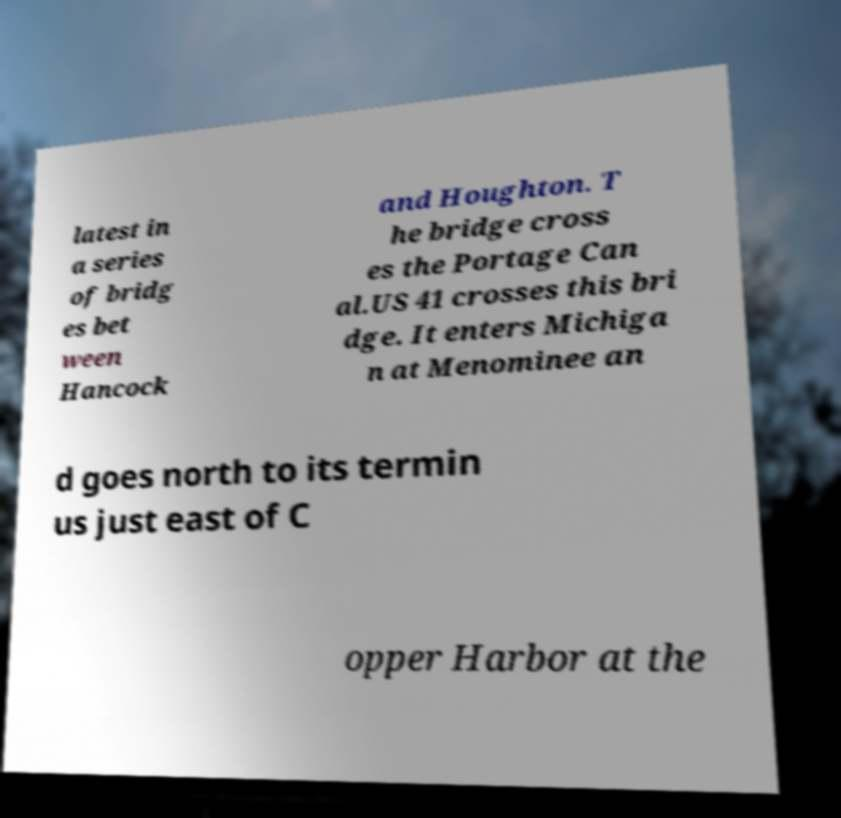Please read and relay the text visible in this image. What does it say? latest in a series of bridg es bet ween Hancock and Houghton. T he bridge cross es the Portage Can al.US 41 crosses this bri dge. It enters Michiga n at Menominee an d goes north to its termin us just east of C opper Harbor at the 